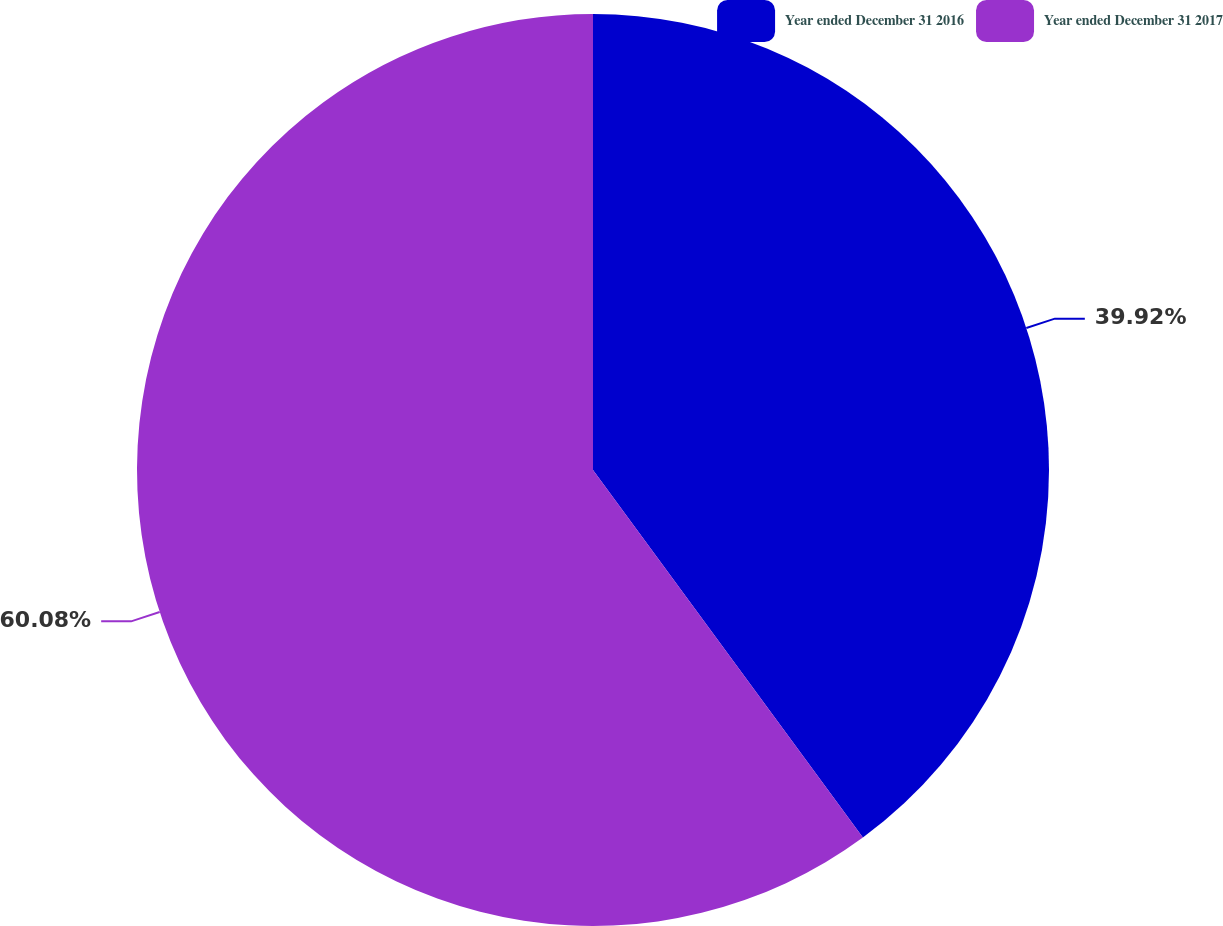Convert chart. <chart><loc_0><loc_0><loc_500><loc_500><pie_chart><fcel>Year ended December 31 2016<fcel>Year ended December 31 2017<nl><fcel>39.92%<fcel>60.08%<nl></chart> 